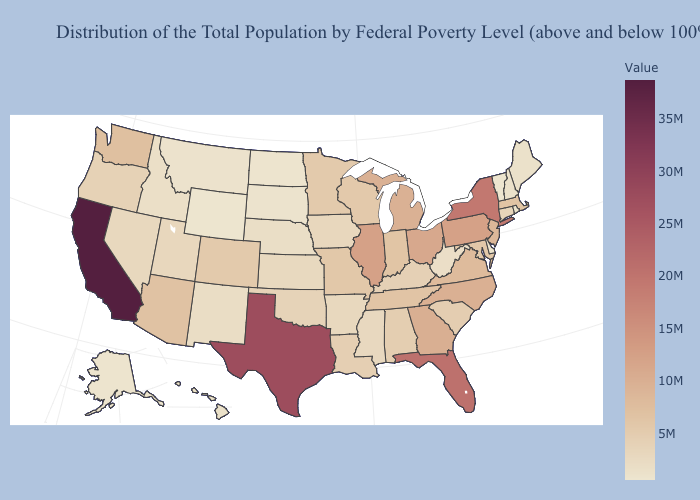Among the states that border Michigan , does Indiana have the highest value?
Short answer required. No. Which states have the highest value in the USA?
Short answer required. California. Among the states that border Maryland , does Pennsylvania have the highest value?
Concise answer only. Yes. Does Pennsylvania have a higher value than Kansas?
Concise answer only. Yes. Among the states that border North Carolina , does South Carolina have the highest value?
Keep it brief. No. 